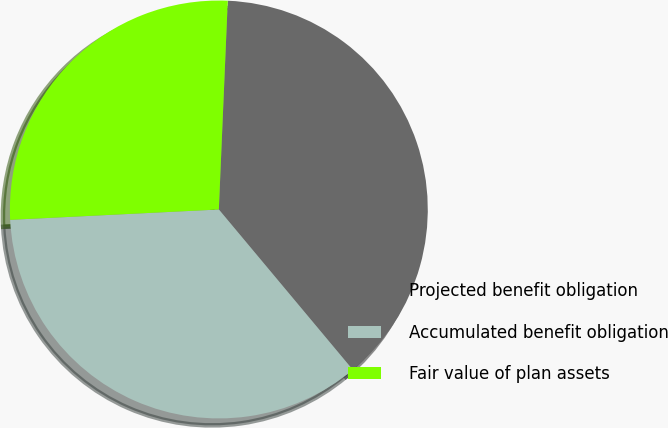Convert chart to OTSL. <chart><loc_0><loc_0><loc_500><loc_500><pie_chart><fcel>Projected benefit obligation<fcel>Accumulated benefit obligation<fcel>Fair value of plan assets<nl><fcel>38.24%<fcel>35.29%<fcel>26.47%<nl></chart> 